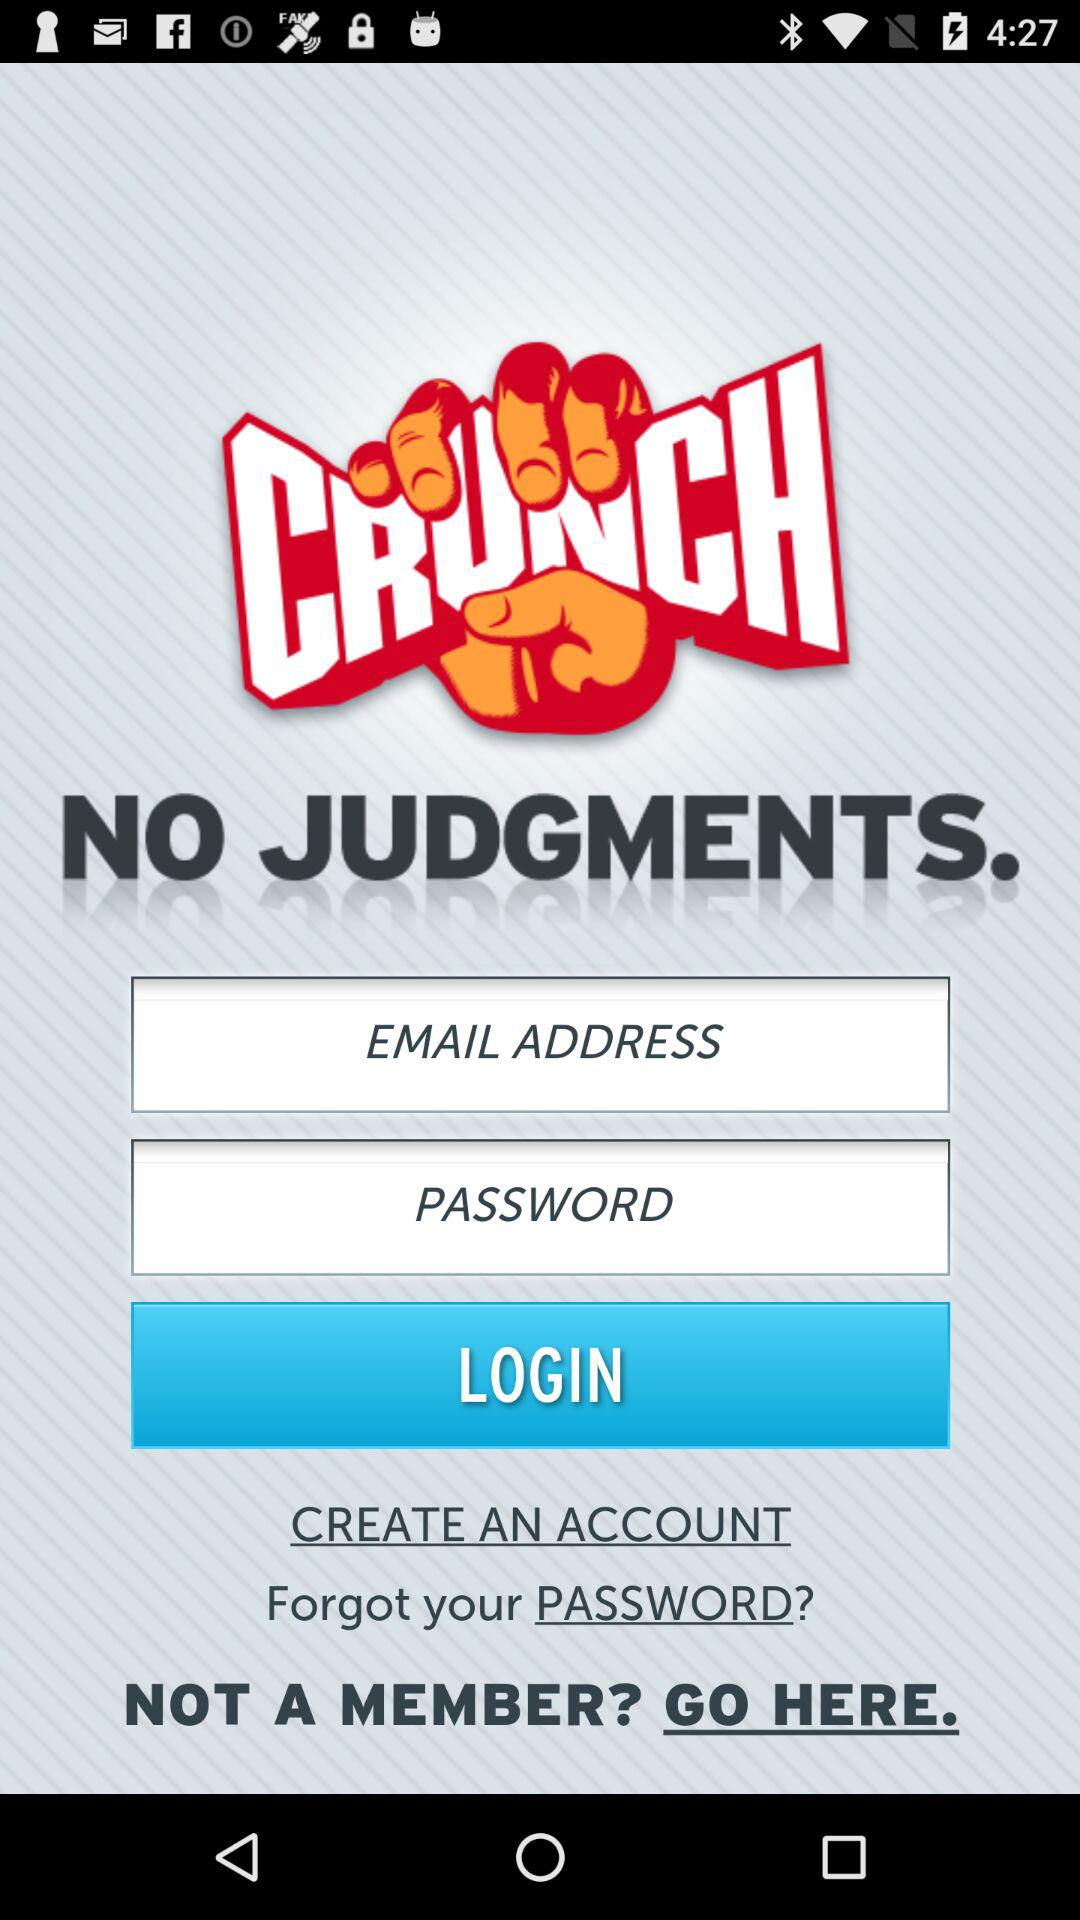What is the name of the application? The name of the application is "Crunch Fitness". 